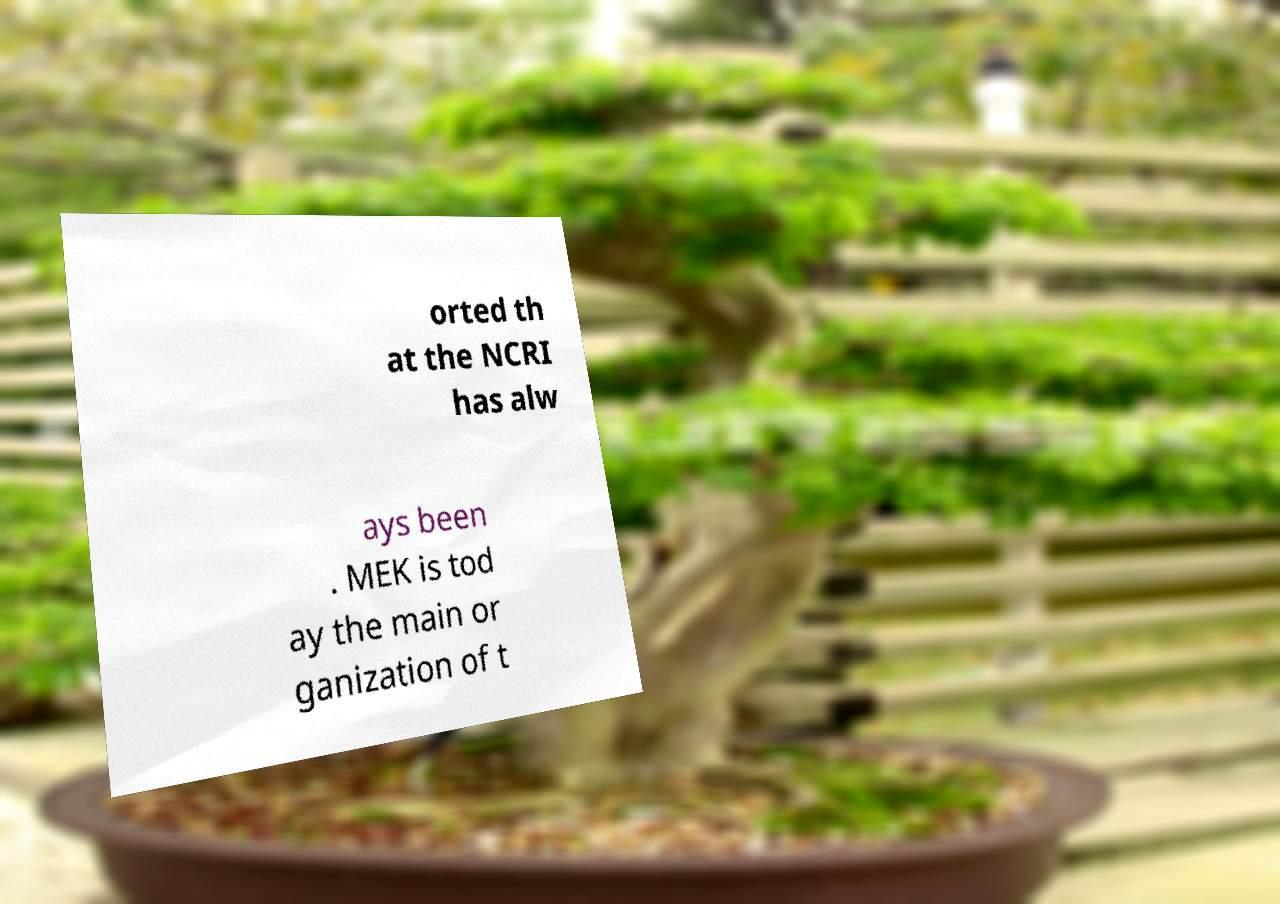Please identify and transcribe the text found in this image. orted th at the NCRI has alw ays been . MEK is tod ay the main or ganization of t 